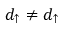Convert formula to latex. <formula><loc_0><loc_0><loc_500><loc_500>d _ { \uparrow } \ne d _ { \uparrow }</formula> 